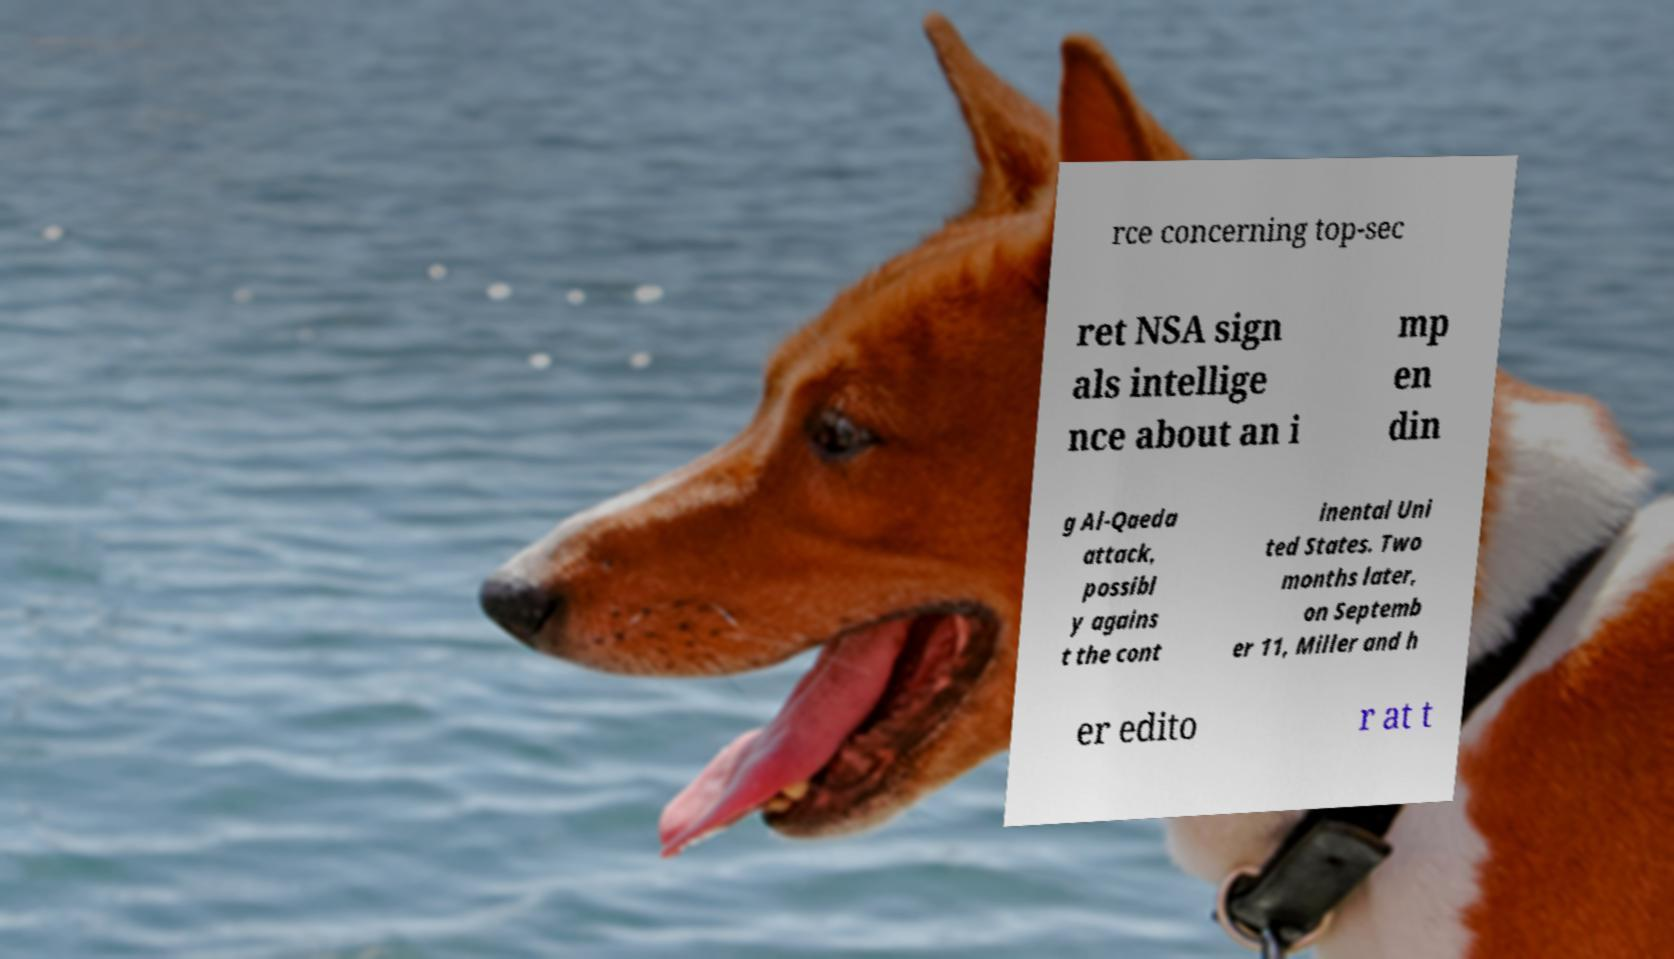Can you accurately transcribe the text from the provided image for me? rce concerning top-sec ret NSA sign als intellige nce about an i mp en din g Al-Qaeda attack, possibl y agains t the cont inental Uni ted States. Two months later, on Septemb er 11, Miller and h er edito r at t 